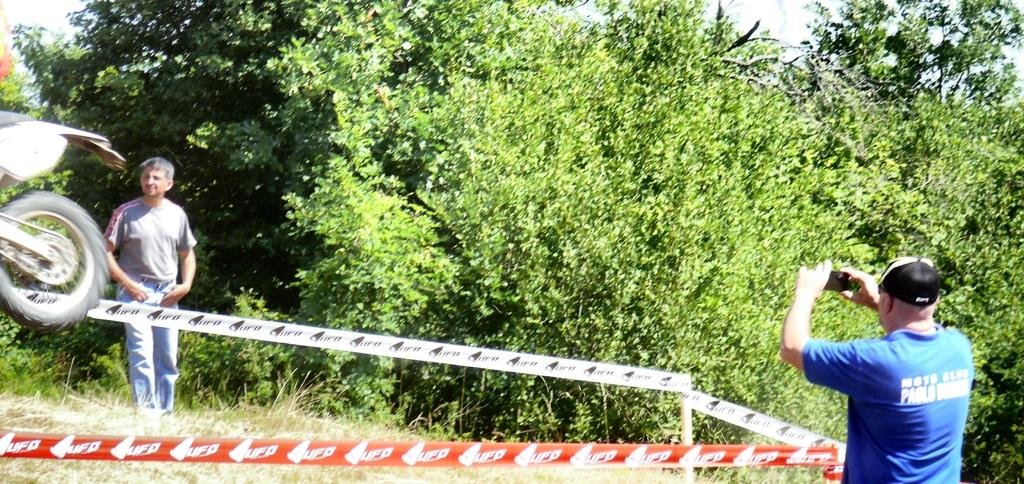What is the main subject of the image? There is a person standing on grass in the image. What is the other person in the image doing? The other person is taking a picture in the image. What can be seen in the middle of the image? There are trees in the middle of the image. What object is located on the left side of the image? There is a bicycle wheel on the left side of the image. What type of rake is being used by the person standing on grass in the image? There is no rake present in the image; the person is simply standing on the grass. How many boys are visible in the image? There is no mention of a boy in the image; it features two adults, one standing on grass and the other taking a picture. 